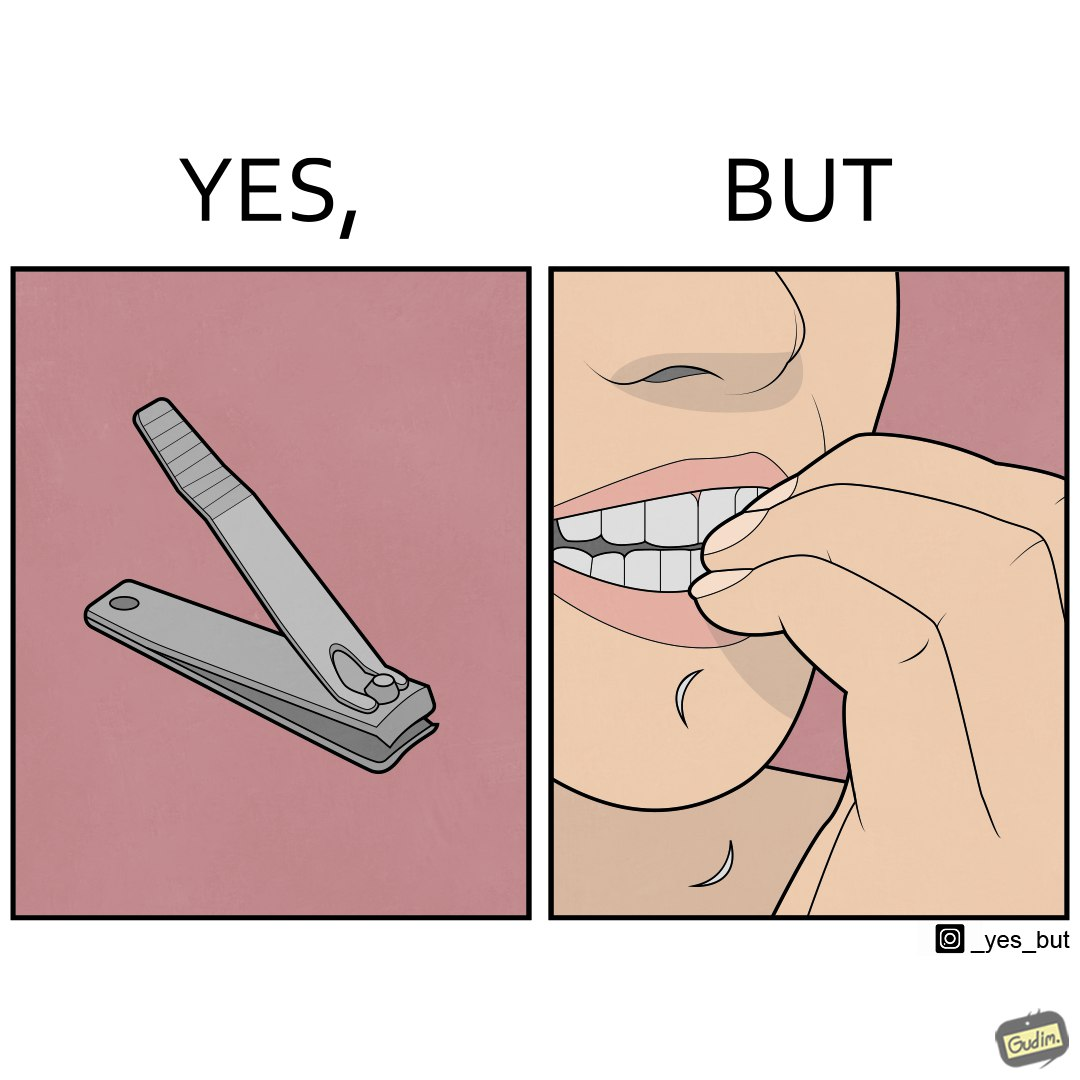What makes this image funny or satirical? The image is ironic, because even after nail clippers are available people prefer biting their nails by teeth 